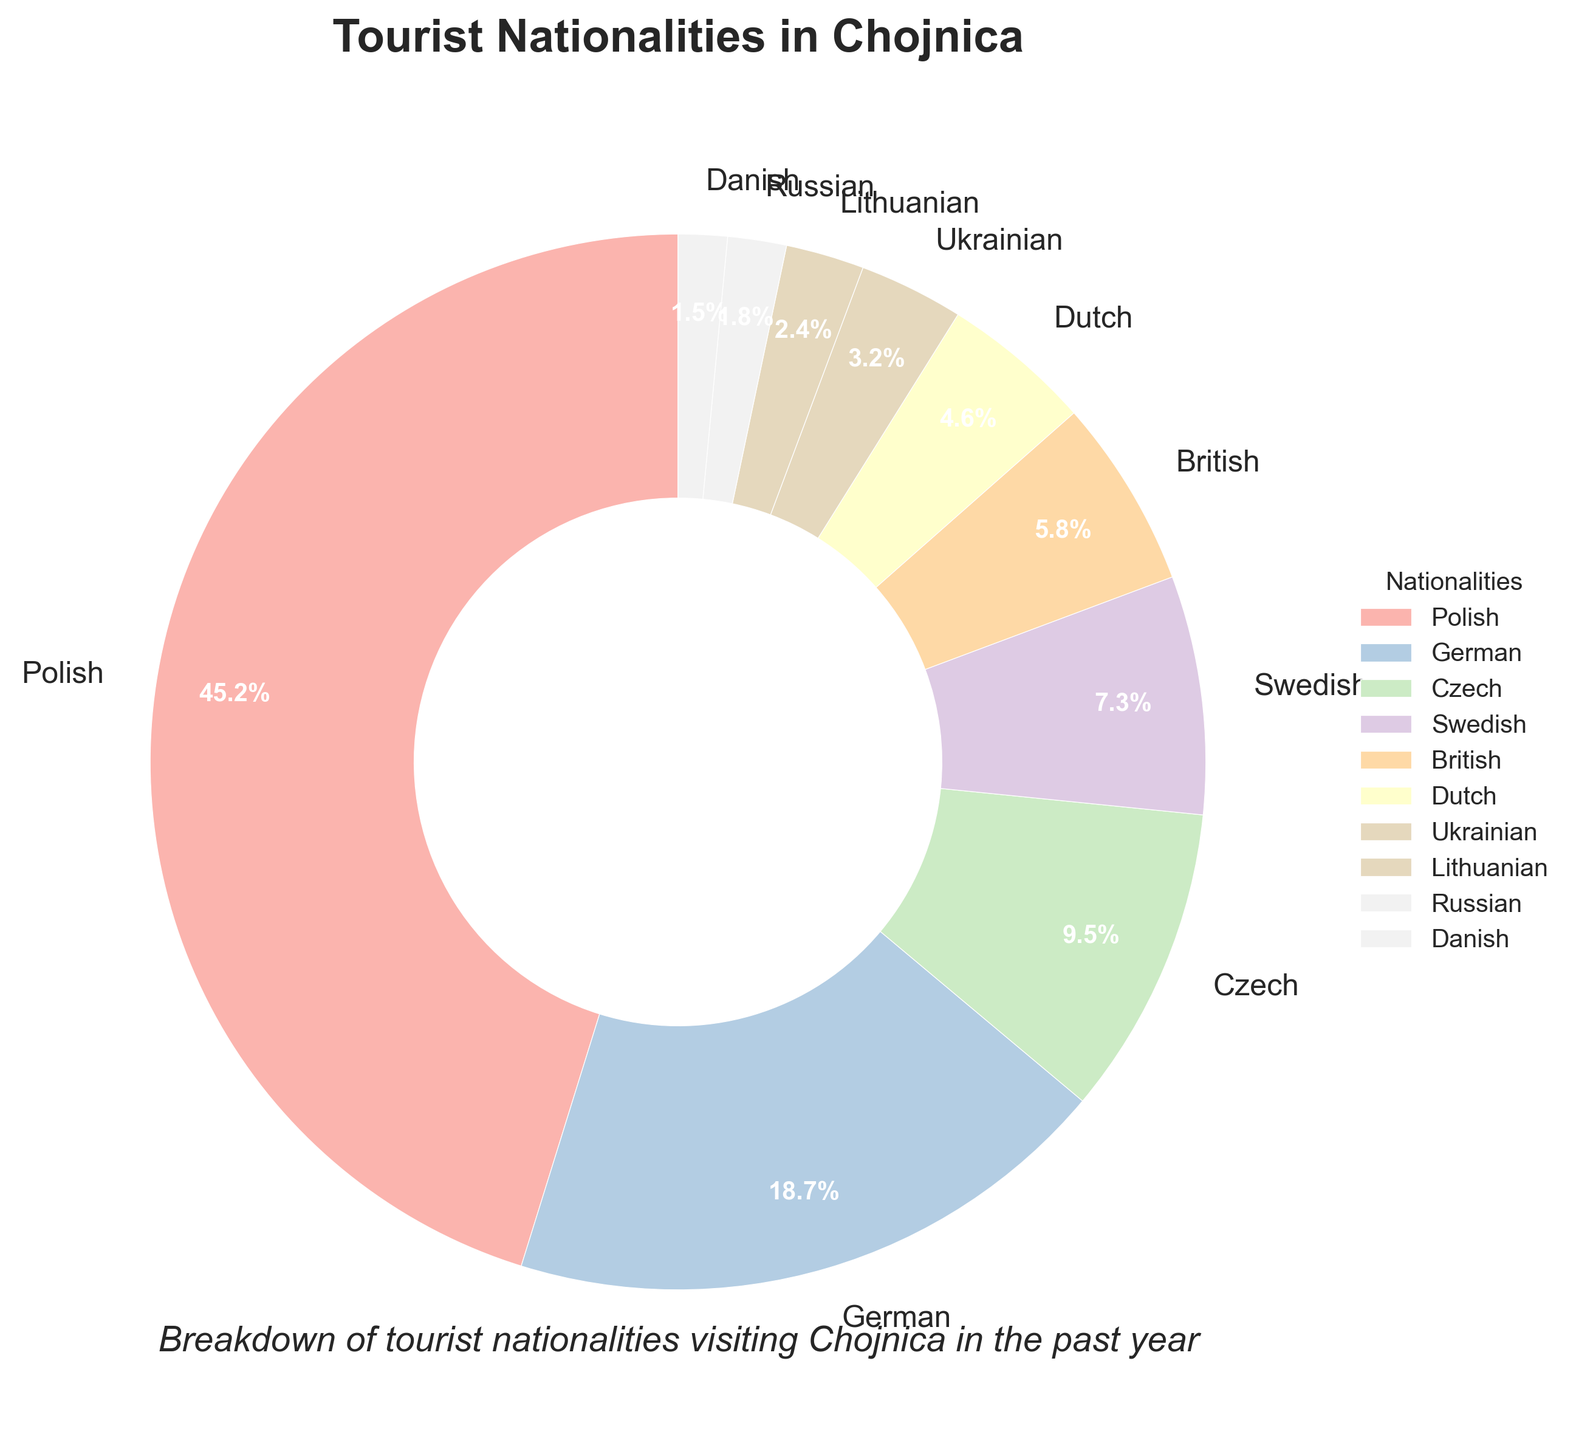What's the total percentage of tourists from Polish and German nationalities? To find the total percentage of Polish and German tourists, sum their respective percentages: 45.2% (Polish) + 18.7% (German) = 63.9%.
Answer: 63.9% What is the difference in percentage between Czech and Ukrainian tourists? Subtract the percentage of Ukrainian tourists from the percentage of Czech tourists: 9.5% (Czech) - 3.2% (Ukrainian) = 6.3%.
Answer: 6.3% Which nationality has the smallest representation in the tourist population? By looking at the pie chart, the nationality with the smallest percentage is the Danish at 1.5%.
Answer: Danish Which nationality has a higher percentage of tourists, Swedish or British? Comparing the percentages, 7.3% (Swedish) and 5.8% (British), the Swedish tourists have a higher percentage.
Answer: Swedish Are there more Dutch tourists or Lithuanian tourists? Compare the percentages of Dutch and Lithuanian tourists: 4.6% (Dutch) is greater than 2.4% (Lithuanian).
Answer: Dutch What is the combined percentage of tourists from Ukrainian, Lithuanian, and Russian nationalities? Add the percentages of Ukrainian, Lithuanian, and Russian tourists: 3.2% + 2.4% + 1.8% = 7.4%.
Answer: 7.4% How does the percentage of Polish tourists compare to the percentage of all other nationalities combined? The percentage of Polish tourists is 45.2%. The combined percentage of all other nationalities is 100% - 45.2% = 54.8%. Thus, Polish tourists are slightly fewer than all other nationalities combined.
Answer: Polish tourists are fewer What is the average percentage of tourists from the top three represented nationalities? The top three represented nationalities are Polish (45.2%), German (18.7%), and Czech (9.5%). To find their average: (45.2% + 18.7% + 9.5%) / 3 = 24.4667%.
Answer: 24.47% Which nationality has a closer percentage of tourists to 5%: Dutch or Swedish? The Dutch have a percentage of 4.6%, and the Swedish have 7.3%. The Dutch percentage (4.6%) is closer to 5% than the Swedish percentage (7.3%).
Answer: Dutch Which nationality is represented by a wedge with the color "blue"? The exact colors from the custom palette are not directly inferable from the data, as the specific color assignments are not provided. Thus, this question cannot be answered without seeing the chart.
Answer: Cannot determine from data provided 